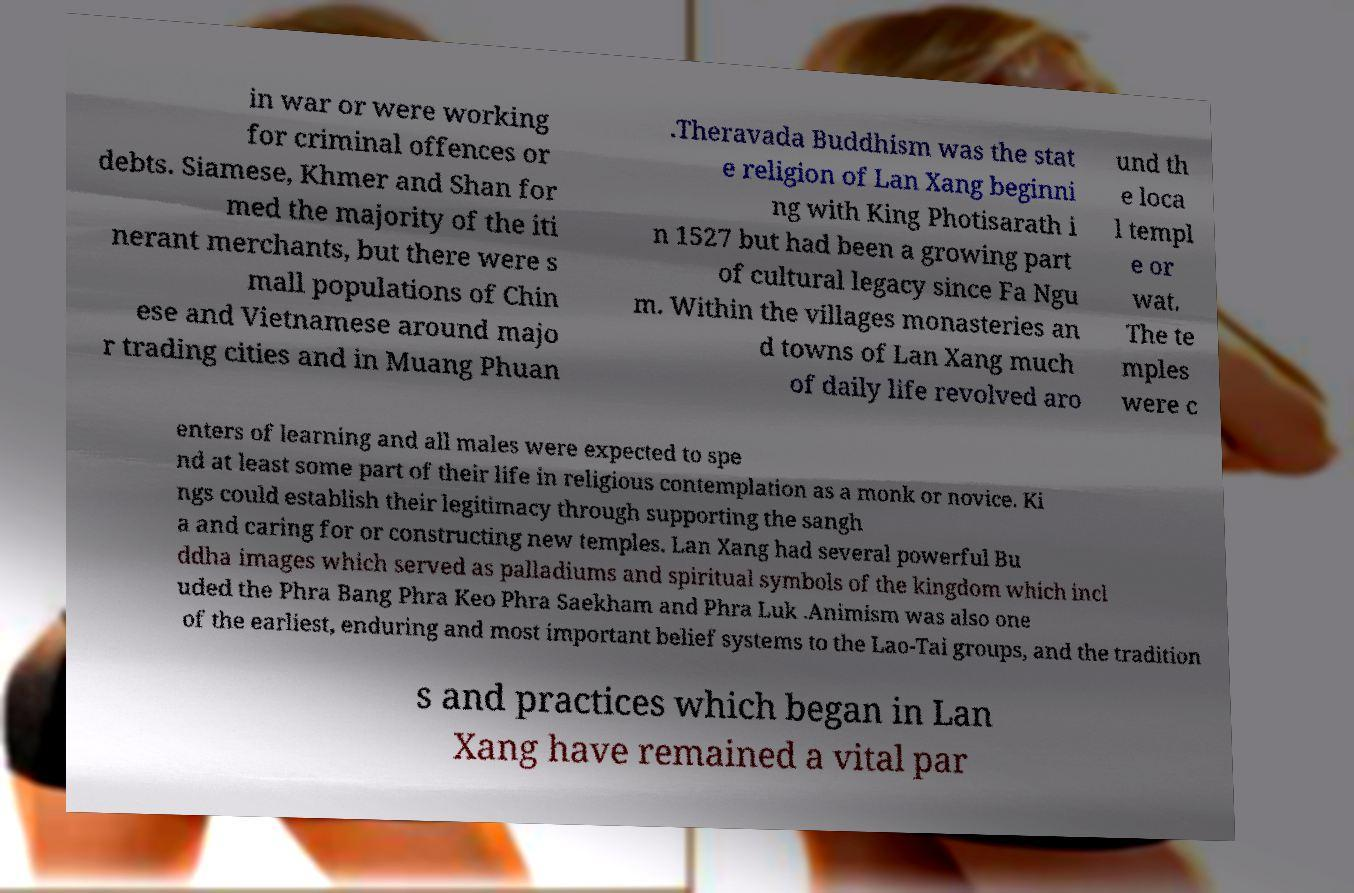Can you read and provide the text displayed in the image?This photo seems to have some interesting text. Can you extract and type it out for me? in war or were working for criminal offences or debts. Siamese, Khmer and Shan for med the majority of the iti nerant merchants, but there were s mall populations of Chin ese and Vietnamese around majo r trading cities and in Muang Phuan .Theravada Buddhism was the stat e religion of Lan Xang beginni ng with King Photisarath i n 1527 but had been a growing part of cultural legacy since Fa Ngu m. Within the villages monasteries an d towns of Lan Xang much of daily life revolved aro und th e loca l templ e or wat. The te mples were c enters of learning and all males were expected to spe nd at least some part of their life in religious contemplation as a monk or novice. Ki ngs could establish their legitimacy through supporting the sangh a and caring for or constructing new temples. Lan Xang had several powerful Bu ddha images which served as palladiums and spiritual symbols of the kingdom which incl uded the Phra Bang Phra Keo Phra Saekham and Phra Luk .Animism was also one of the earliest, enduring and most important belief systems to the Lao-Tai groups, and the tradition s and practices which began in Lan Xang have remained a vital par 